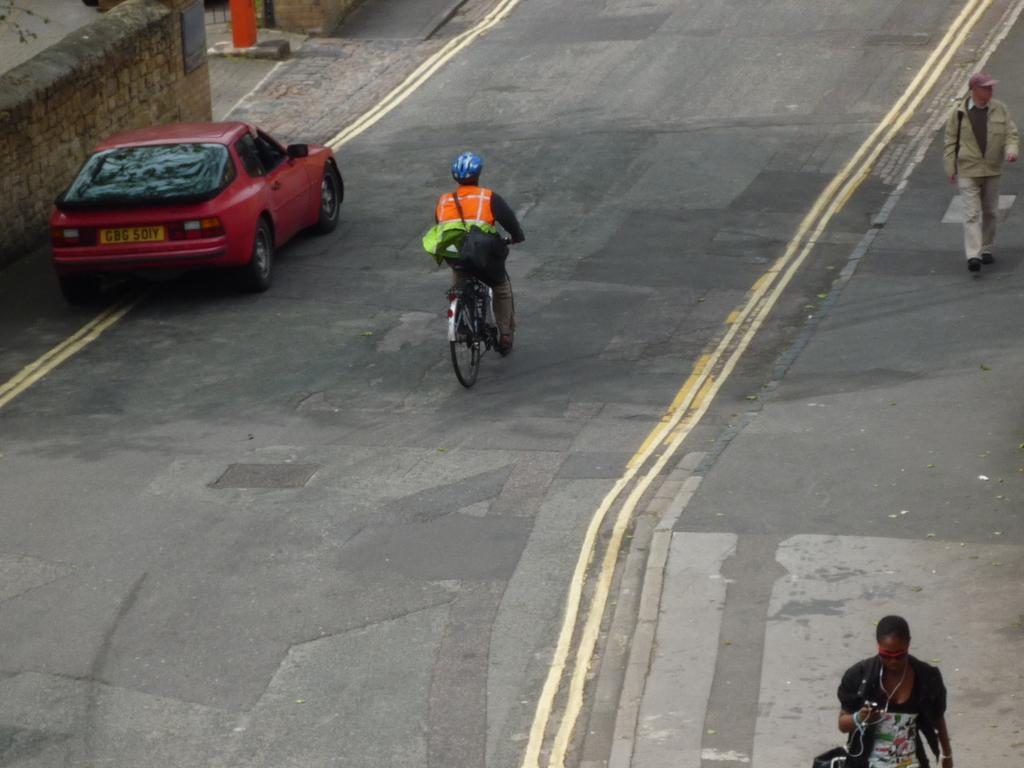What is the person in the image doing? The person is sitting on a bicycle in the image. What else can be seen on the road in the image? A car is parked on the road in the image. What are the people on the footpath doing? People are walking on the footpath in the image. What color is the person's hair in the image? There is no information about the person's hair color in the image. Is there any blood visible in the image? There is no blood visible in the image. 